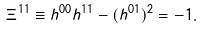Convert formula to latex. <formula><loc_0><loc_0><loc_500><loc_500>\Xi ^ { 1 1 } \equiv h ^ { 0 0 } h ^ { 1 1 } - ( h ^ { 0 1 } ) ^ { 2 } = - 1 .</formula> 